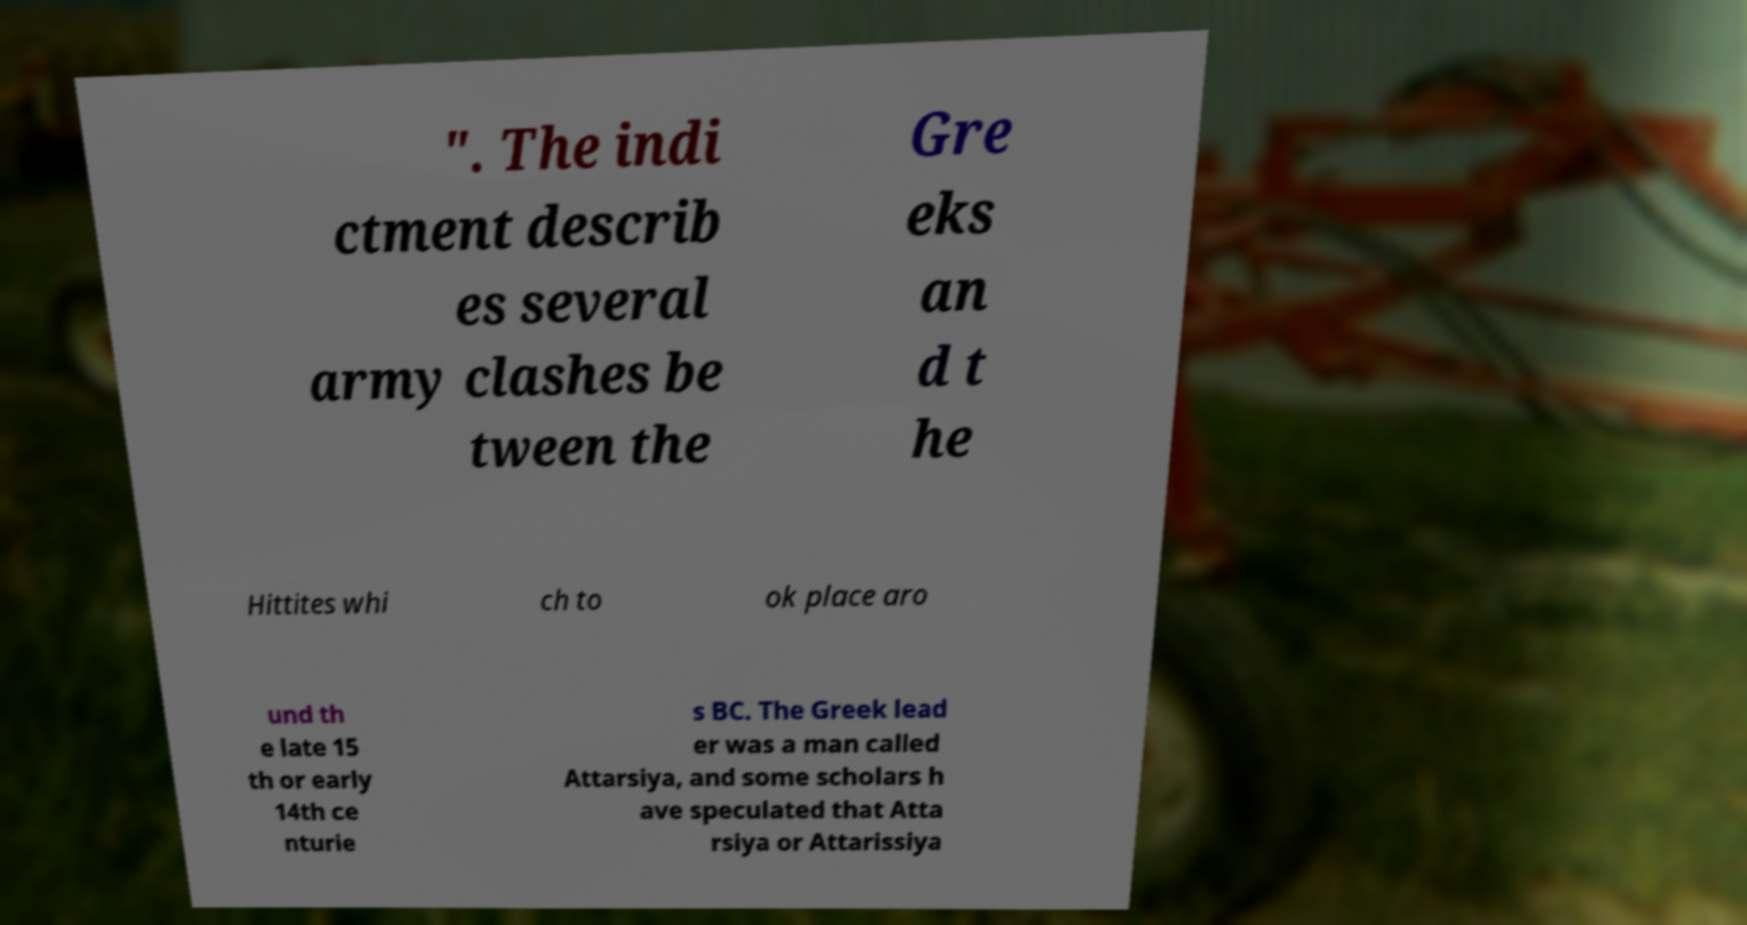Could you assist in decoding the text presented in this image and type it out clearly? ". The indi ctment describ es several army clashes be tween the Gre eks an d t he Hittites whi ch to ok place aro und th e late 15 th or early 14th ce nturie s BC. The Greek lead er was a man called Attarsiya, and some scholars h ave speculated that Atta rsiya or Attarissiya 